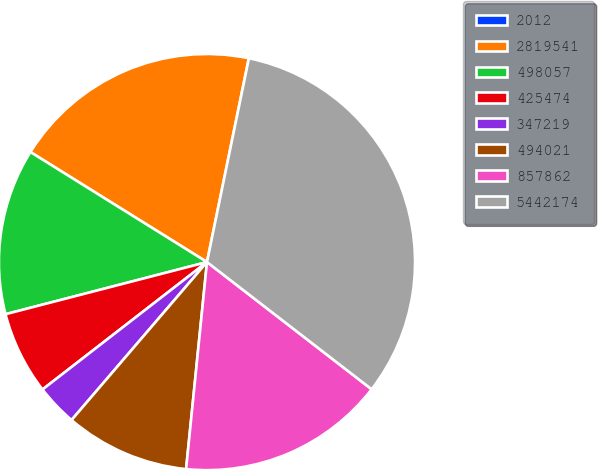Convert chart. <chart><loc_0><loc_0><loc_500><loc_500><pie_chart><fcel>2012<fcel>2819541<fcel>498057<fcel>425474<fcel>347219<fcel>494021<fcel>857862<fcel>5442174<nl><fcel>0.01%<fcel>19.35%<fcel>12.9%<fcel>6.46%<fcel>3.23%<fcel>9.68%<fcel>16.13%<fcel>32.24%<nl></chart> 